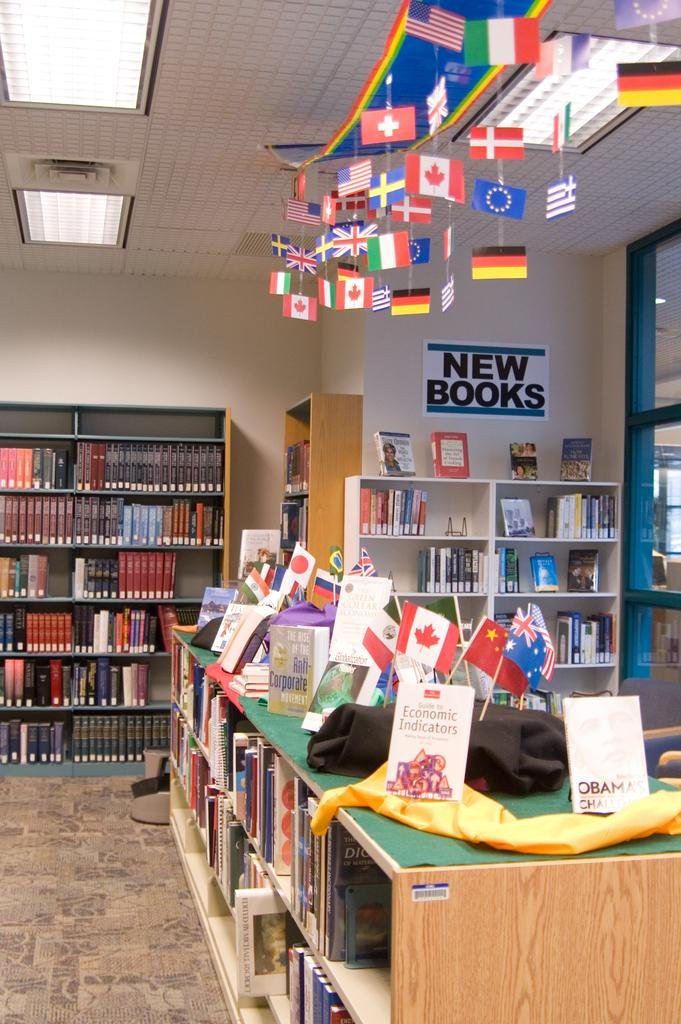<image>
Give a short and clear explanation of the subsequent image. Library full of books with various flags hanging and section with sign saying new books. 